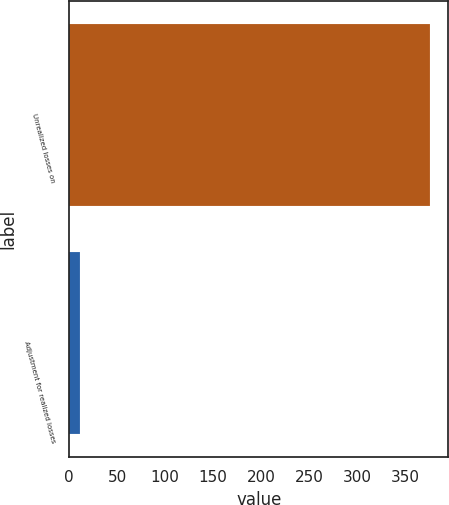Convert chart. <chart><loc_0><loc_0><loc_500><loc_500><bar_chart><fcel>Unrealized losses on<fcel>Adjustment for realized losses<nl><fcel>376<fcel>11.9<nl></chart> 